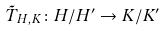Convert formula to latex. <formula><loc_0><loc_0><loc_500><loc_500>\tilde { T } _ { H , K } \colon H / H ^ { \prime } \rightarrow K / K ^ { \prime }</formula> 